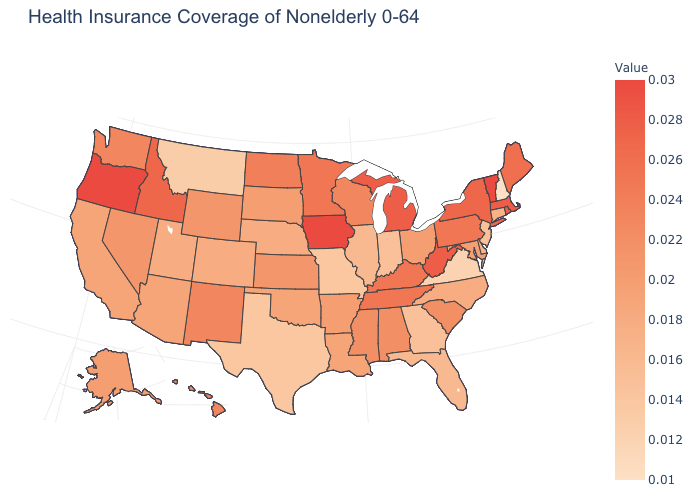Does Delaware have a higher value than Missouri?
Answer briefly. Yes. Which states have the highest value in the USA?
Be succinct. Iowa, Oregon, Vermont. Does Delaware have a higher value than Hawaii?
Answer briefly. No. Which states have the highest value in the USA?
Concise answer only. Iowa, Oregon, Vermont. Which states have the lowest value in the USA?
Give a very brief answer. New Hampshire. Among the states that border Alabama , which have the highest value?
Write a very short answer. Tennessee. 